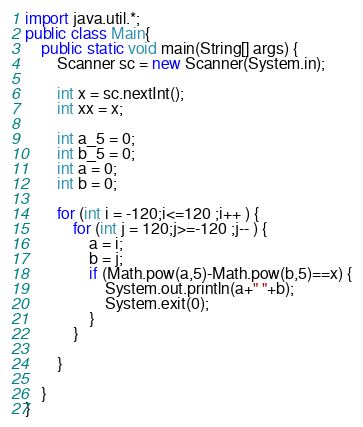<code> <loc_0><loc_0><loc_500><loc_500><_Java_>import java.util.*;
public class Main{
	public static void main(String[] args) {
		Scanner sc = new Scanner(System.in);

		int x = sc.nextInt();
		int xx = x;

		int a_5 = 0;
		int b_5 = 0;
		int a = 0;
		int b = 0;

		for (int i = -120;i<=120 ;i++ ) {
			for (int j = 120;j>=-120 ;j-- ) {
				a = i;
				b = j;
				if (Math.pow(a,5)-Math.pow(b,5)==x) {
					System.out.println(a+" "+b);
					System.exit(0);
				}
			}

		}

	}
}
</code> 